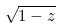<formula> <loc_0><loc_0><loc_500><loc_500>\sqrt { 1 - z }</formula> 